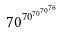Convert formula to latex. <formula><loc_0><loc_0><loc_500><loc_500>7 0 ^ { 7 0 ^ { 7 0 ^ { 7 0 ^ { 7 6 } } } }</formula> 